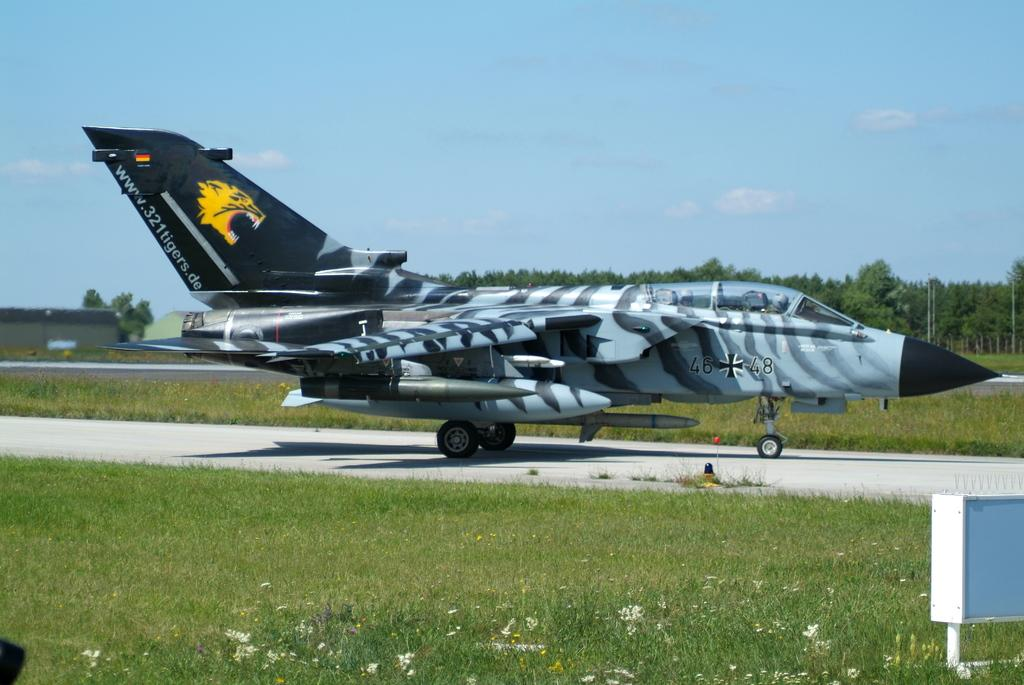<image>
Describe the image concisely. a blue and black striped military plane with www.321tigers.de on the tail 